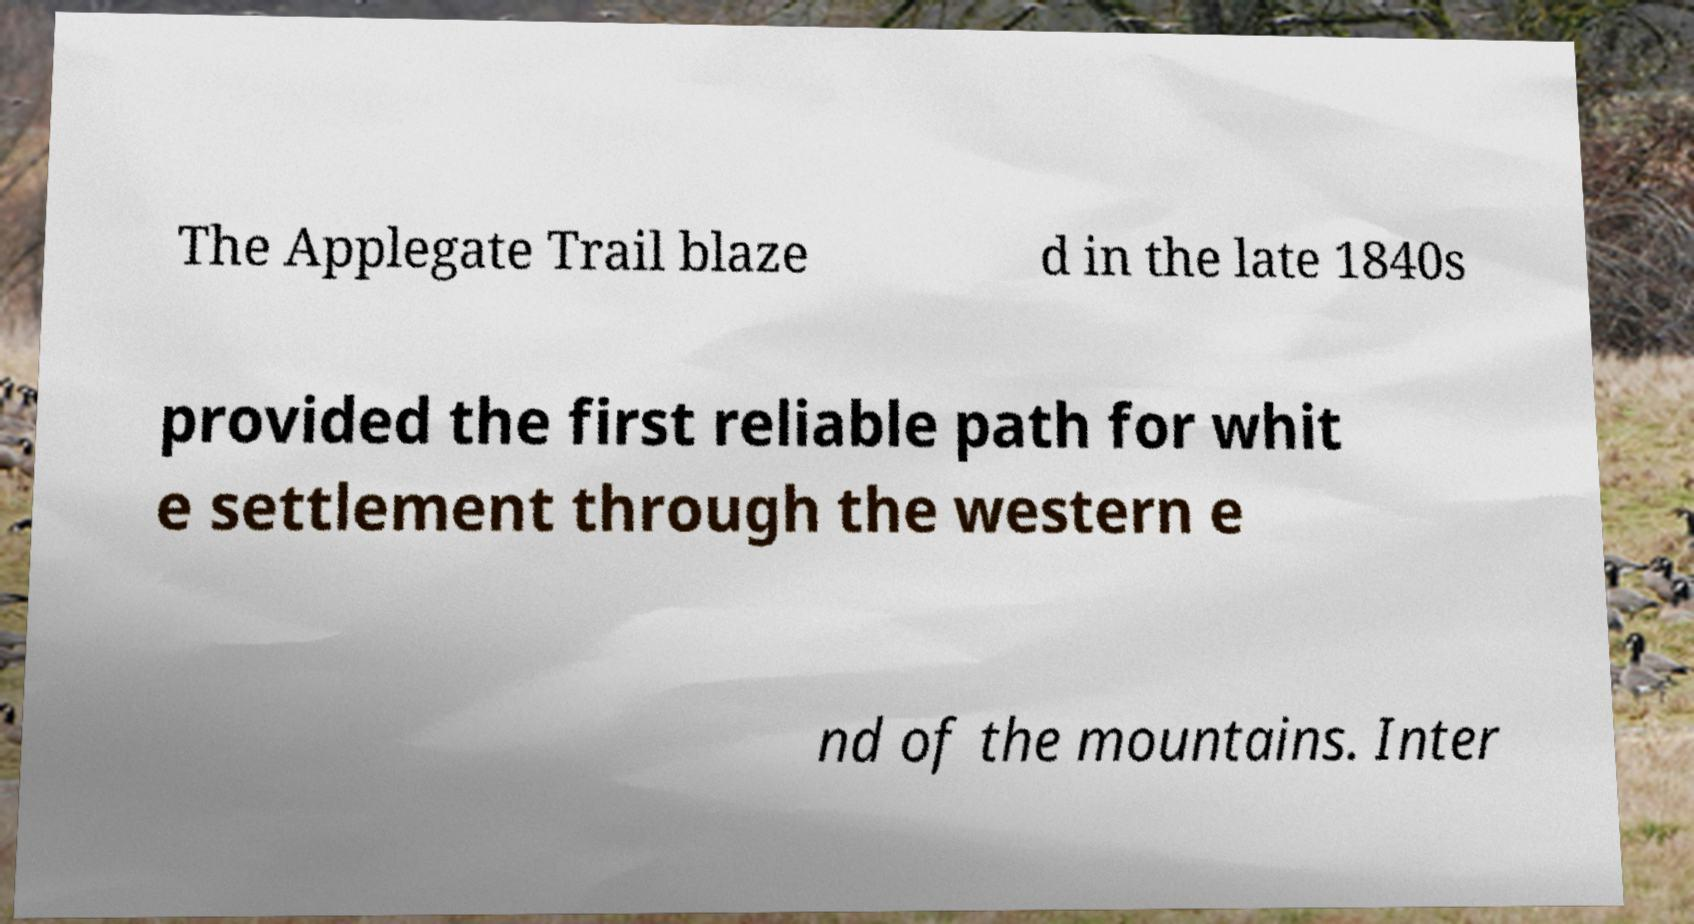Please read and relay the text visible in this image. What does it say? The Applegate Trail blaze d in the late 1840s provided the first reliable path for whit e settlement through the western e nd of the mountains. Inter 